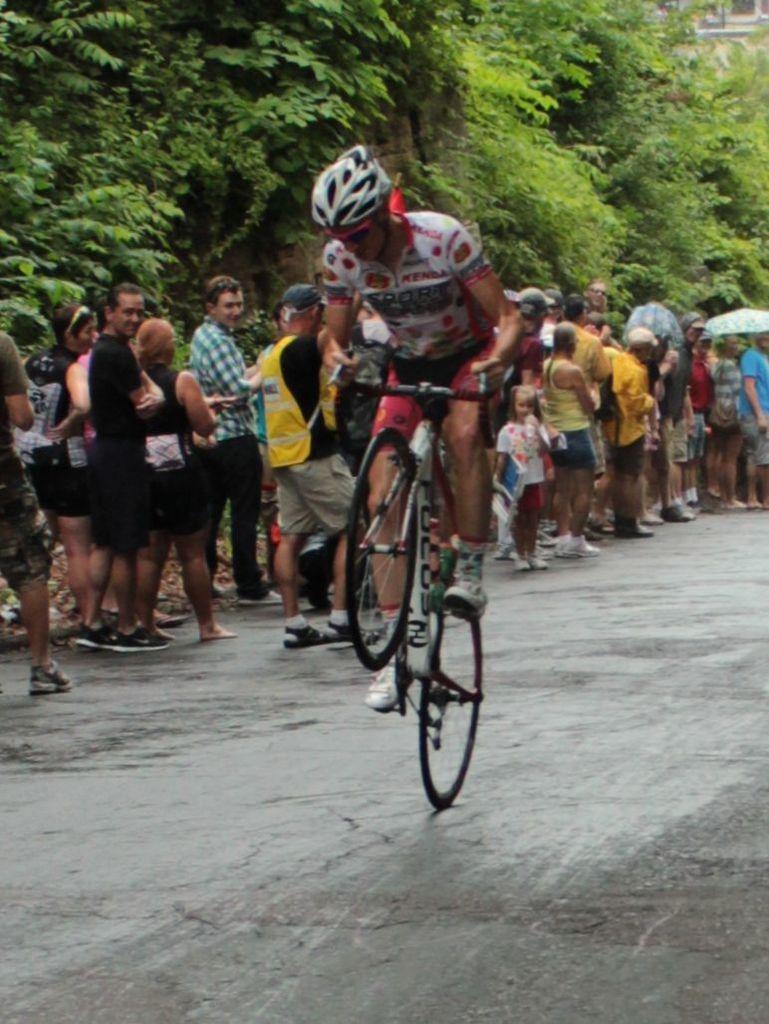Can you describe this image briefly? This is a picture of a person who is riding a bicycle and behind him there are some people standing in the line in opposite direction and beside them there are some trees. 